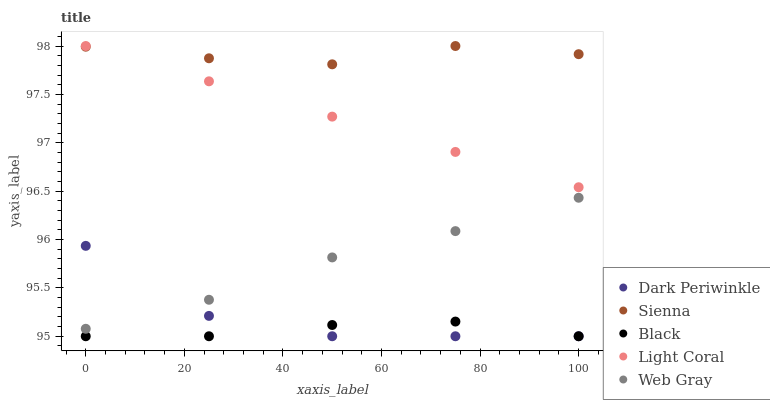Does Black have the minimum area under the curve?
Answer yes or no. Yes. Does Sienna have the maximum area under the curve?
Answer yes or no. Yes. Does Light Coral have the minimum area under the curve?
Answer yes or no. No. Does Light Coral have the maximum area under the curve?
Answer yes or no. No. Is Light Coral the smoothest?
Answer yes or no. Yes. Is Dark Periwinkle the roughest?
Answer yes or no. Yes. Is Web Gray the smoothest?
Answer yes or no. No. Is Web Gray the roughest?
Answer yes or no. No. Does Black have the lowest value?
Answer yes or no. Yes. Does Light Coral have the lowest value?
Answer yes or no. No. Does Light Coral have the highest value?
Answer yes or no. Yes. Does Web Gray have the highest value?
Answer yes or no. No. Is Web Gray less than Light Coral?
Answer yes or no. Yes. Is Light Coral greater than Web Gray?
Answer yes or no. Yes. Does Sienna intersect Light Coral?
Answer yes or no. Yes. Is Sienna less than Light Coral?
Answer yes or no. No. Is Sienna greater than Light Coral?
Answer yes or no. No. Does Web Gray intersect Light Coral?
Answer yes or no. No. 